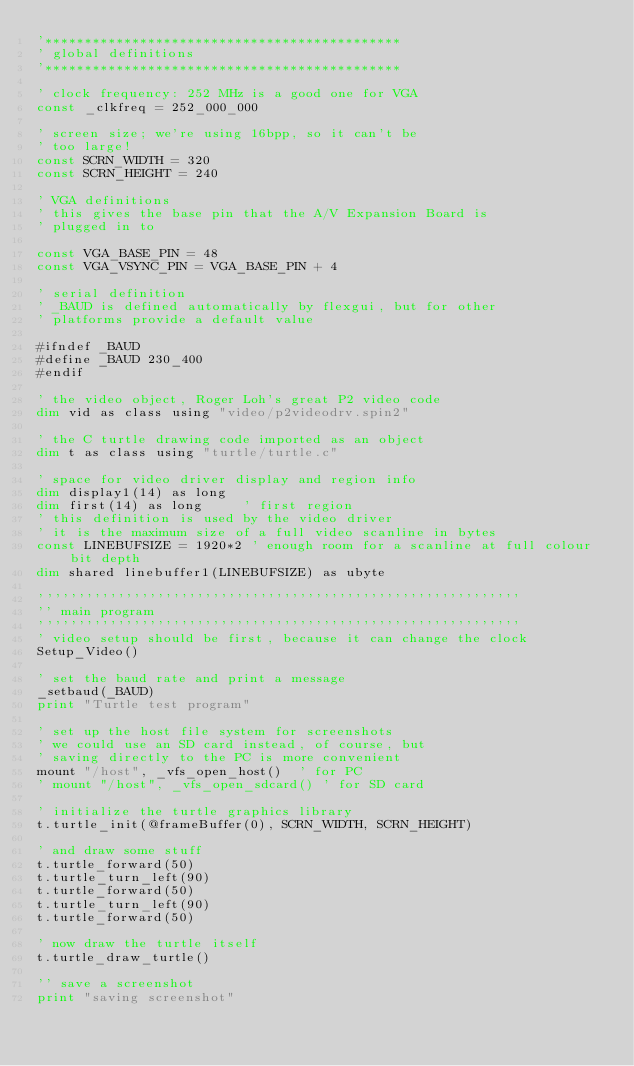Convert code to text. <code><loc_0><loc_0><loc_500><loc_500><_VisualBasic_>'*********************************************
' global definitions
'*********************************************

' clock frequency: 252 MHz is a good one for VGA
const _clkfreq = 252_000_000

' screen size; we're using 16bpp, so it can't be
' too large!
const SCRN_WIDTH = 320
const SCRN_HEIGHT = 240

' VGA definitions
' this gives the base pin that the A/V Expansion Board is
' plugged in to

const VGA_BASE_PIN = 48
const VGA_VSYNC_PIN = VGA_BASE_PIN + 4

' serial definition
' _BAUD is defined automatically by flexgui, but for other
' platforms provide a default value

#ifndef _BAUD
#define _BAUD 230_400
#endif

' the video object, Roger Loh's great P2 video code
dim vid as class using "video/p2videodrv.spin2"

' the C turtle drawing code imported as an object
dim t as class using "turtle/turtle.c"

' space for video driver display and region info
dim display1(14) as long
dim first(14) as long     ' first region
' this definition is used by the video driver
' it is the maximum size of a full video scanline in bytes
const LINEBUFSIZE = 1920*2 ' enough room for a scanline at full colour bit depth
dim shared linebuffer1(LINEBUFSIZE) as ubyte

'''''''''''''''''''''''''''''''''''''''''''''''''''''''''''''
'' main program
'''''''''''''''''''''''''''''''''''''''''''''''''''''''''''''
' video setup should be first, because it can change the clock
Setup_Video()

' set the baud rate and print a message
_setbaud(_BAUD)
print "Turtle test program"

' set up the host file system for screenshots
' we could use an SD card instead, of course, but
' saving directly to the PC is more convenient
mount "/host", _vfs_open_host()  ' for PC
' mount "/host", _vfs_open_sdcard() ' for SD card

' initialize the turtle graphics library
t.turtle_init(@frameBuffer(0), SCRN_WIDTH, SCRN_HEIGHT)

' and draw some stuff
t.turtle_forward(50)
t.turtle_turn_left(90)
t.turtle_forward(50)
t.turtle_turn_left(90)
t.turtle_forward(50)

' now draw the turtle itself
t.turtle_draw_turtle()

'' save a screenshot
print "saving screenshot"</code> 